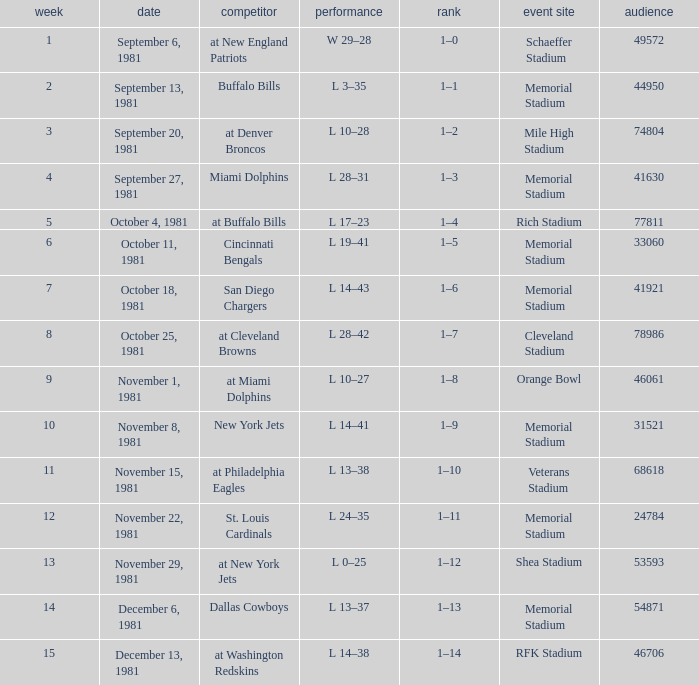Parse the table in full. {'header': ['week', 'date', 'competitor', 'performance', 'rank', 'event site', 'audience'], 'rows': [['1', 'September 6, 1981', 'at New England Patriots', 'W 29–28', '1–0', 'Schaeffer Stadium', '49572'], ['2', 'September 13, 1981', 'Buffalo Bills', 'L 3–35', '1–1', 'Memorial Stadium', '44950'], ['3', 'September 20, 1981', 'at Denver Broncos', 'L 10–28', '1–2', 'Mile High Stadium', '74804'], ['4', 'September 27, 1981', 'Miami Dolphins', 'L 28–31', '1–3', 'Memorial Stadium', '41630'], ['5', 'October 4, 1981', 'at Buffalo Bills', 'L 17–23', '1–4', 'Rich Stadium', '77811'], ['6', 'October 11, 1981', 'Cincinnati Bengals', 'L 19–41', '1–5', 'Memorial Stadium', '33060'], ['7', 'October 18, 1981', 'San Diego Chargers', 'L 14–43', '1–6', 'Memorial Stadium', '41921'], ['8', 'October 25, 1981', 'at Cleveland Browns', 'L 28–42', '1–7', 'Cleveland Stadium', '78986'], ['9', 'November 1, 1981', 'at Miami Dolphins', 'L 10–27', '1–8', 'Orange Bowl', '46061'], ['10', 'November 8, 1981', 'New York Jets', 'L 14–41', '1–9', 'Memorial Stadium', '31521'], ['11', 'November 15, 1981', 'at Philadelphia Eagles', 'L 13–38', '1–10', 'Veterans Stadium', '68618'], ['12', 'November 22, 1981', 'St. Louis Cardinals', 'L 24–35', '1–11', 'Memorial Stadium', '24784'], ['13', 'November 29, 1981', 'at New York Jets', 'L 0–25', '1–12', 'Shea Stadium', '53593'], ['14', 'December 6, 1981', 'Dallas Cowboys', 'L 13–37', '1–13', 'Memorial Stadium', '54871'], ['15', 'December 13, 1981', 'at Washington Redskins', 'L 14–38', '1–14', 'RFK Stadium', '46706']]} When it is October 25, 1981 who is the opponent? At cleveland browns. 